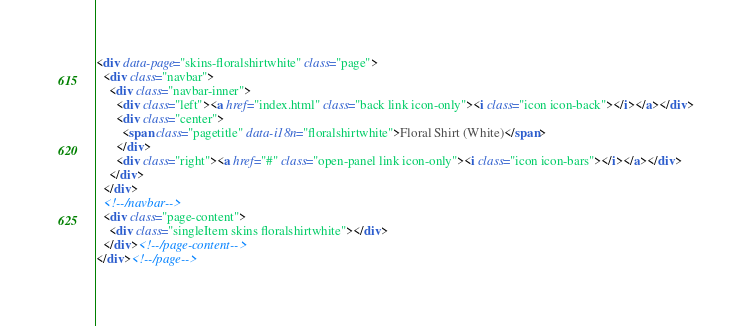<code> <loc_0><loc_0><loc_500><loc_500><_HTML_>
<div data-page="skins-floralshirtwhite" class="page">
  <div class="navbar">
    <div class="navbar-inner">
      <div class="left"><a href="index.html" class="back link icon-only"><i class="icon icon-back"></i></a></div>
      <div class="center">
        <span class="pagetitle" data-i18n="floralshirtwhite">Floral Shirt (White)</span>
      </div>
      <div class="right"><a href="#" class="open-panel link icon-only"><i class="icon icon-bars"></i></a></div>
    </div>
  </div>
  <!--/navbar-->
  <div class="page-content">
    <div class="singleItem skins floralshirtwhite"></div>
  </div><!--/page-content-->
</div><!--/page-->
</code> 